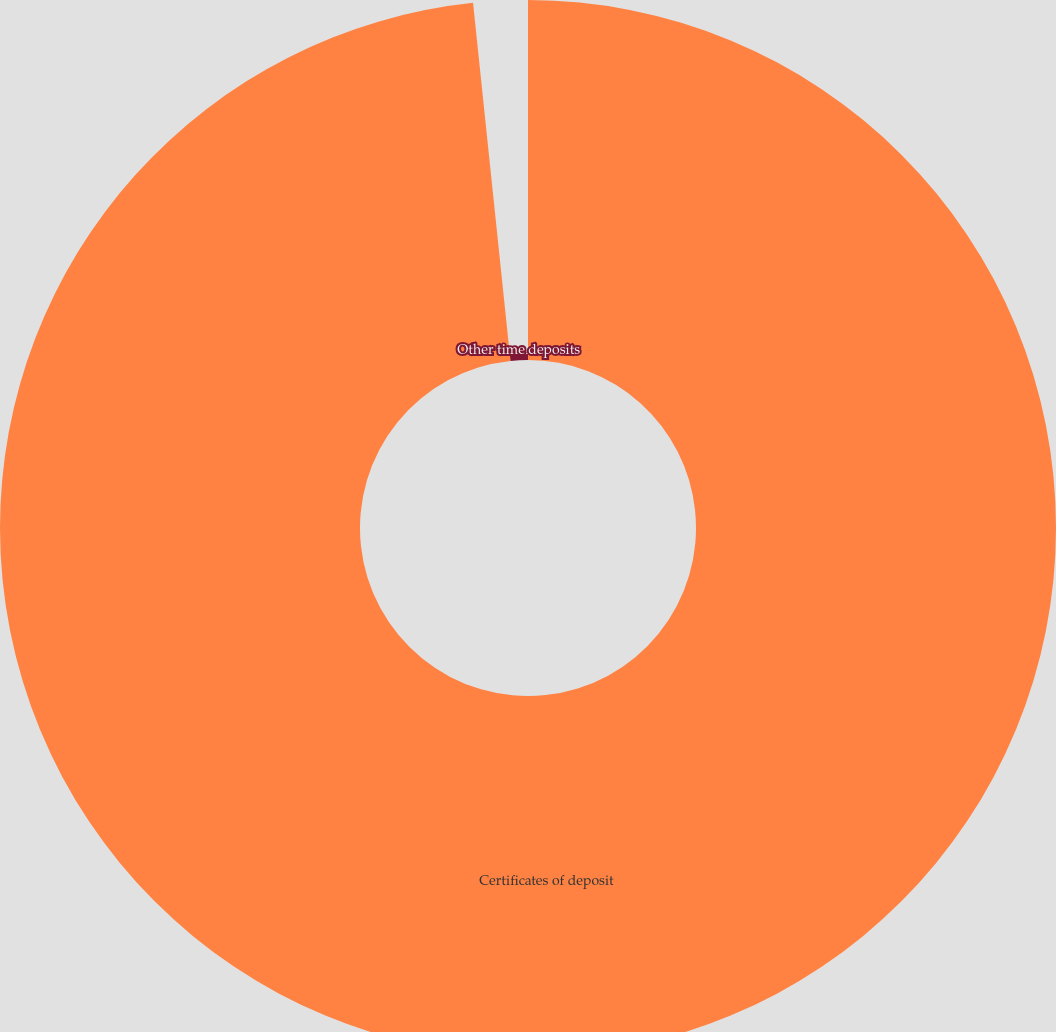Convert chart. <chart><loc_0><loc_0><loc_500><loc_500><pie_chart><fcel>Certificates of deposit<fcel>Other time deposits<nl><fcel>98.34%<fcel>1.66%<nl></chart> 